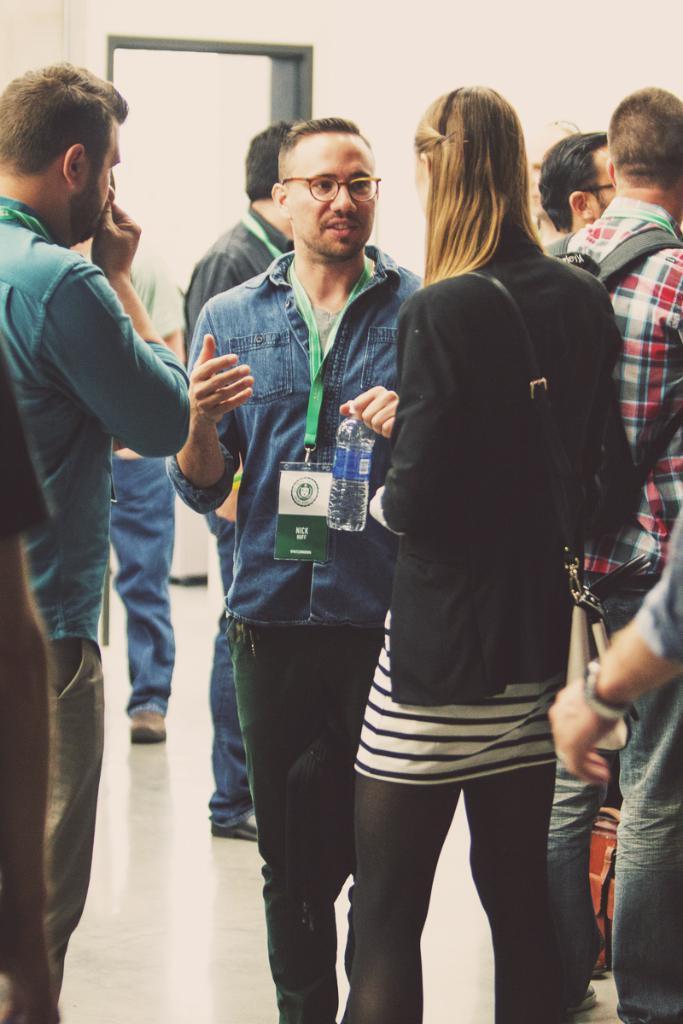In one or two sentences, can you explain what this image depicts? In this image, we can see people and some are wearing id cards and there is a person holding a bottle and we can see a man wearing a bag. In the background, there is a wall. At the bottom, there is a floor. 